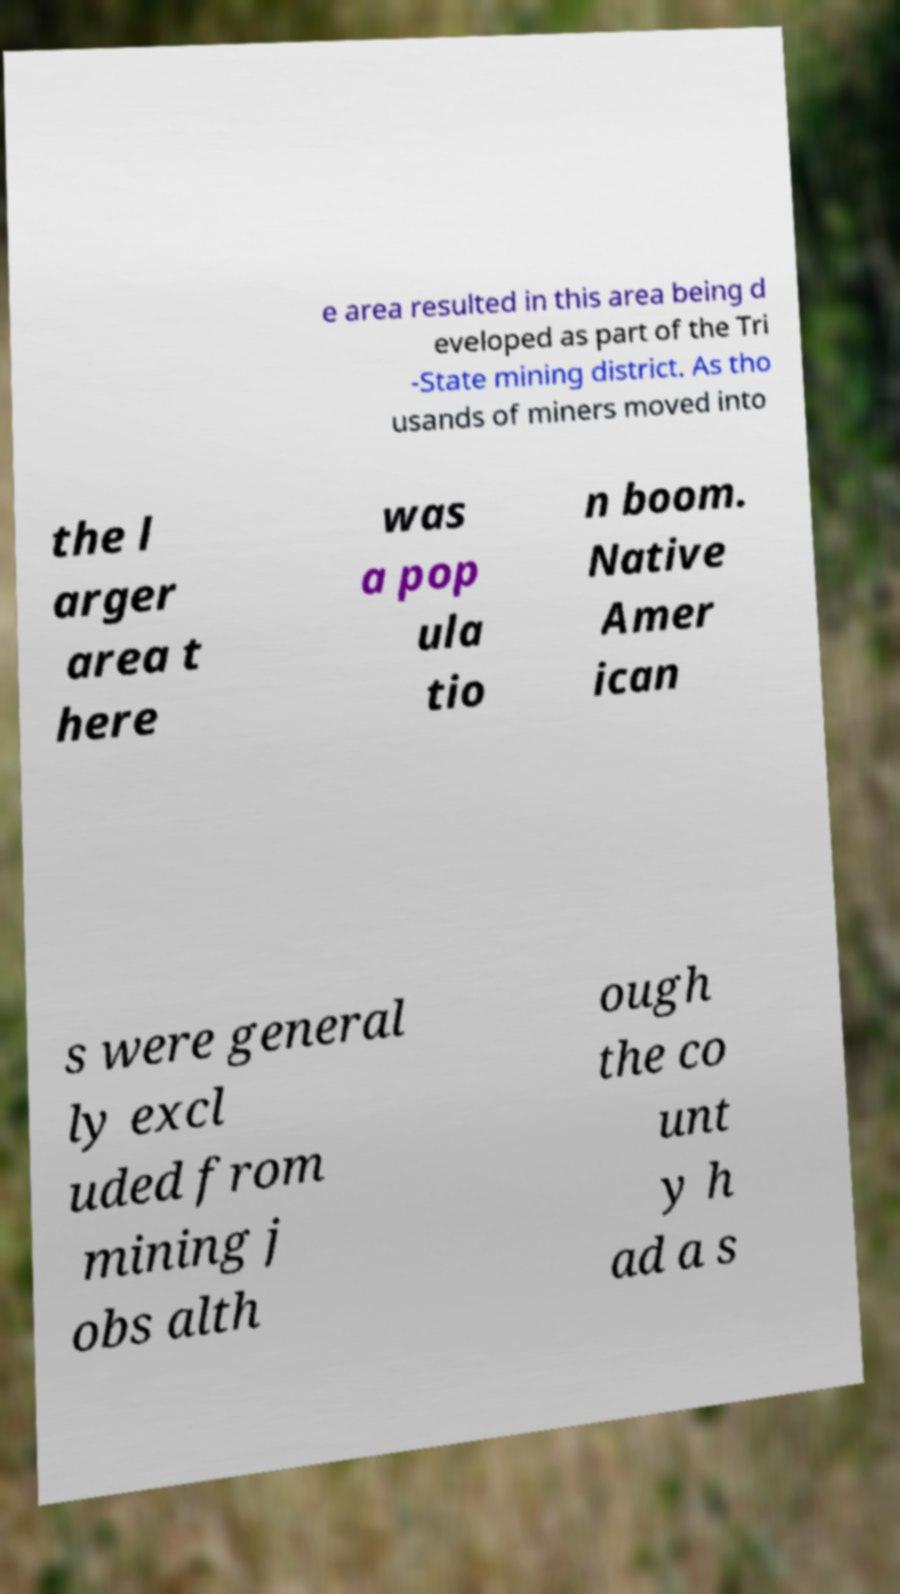Please read and relay the text visible in this image. What does it say? e area resulted in this area being d eveloped as part of the Tri -State mining district. As tho usands of miners moved into the l arger area t here was a pop ula tio n boom. Native Amer ican s were general ly excl uded from mining j obs alth ough the co unt y h ad a s 